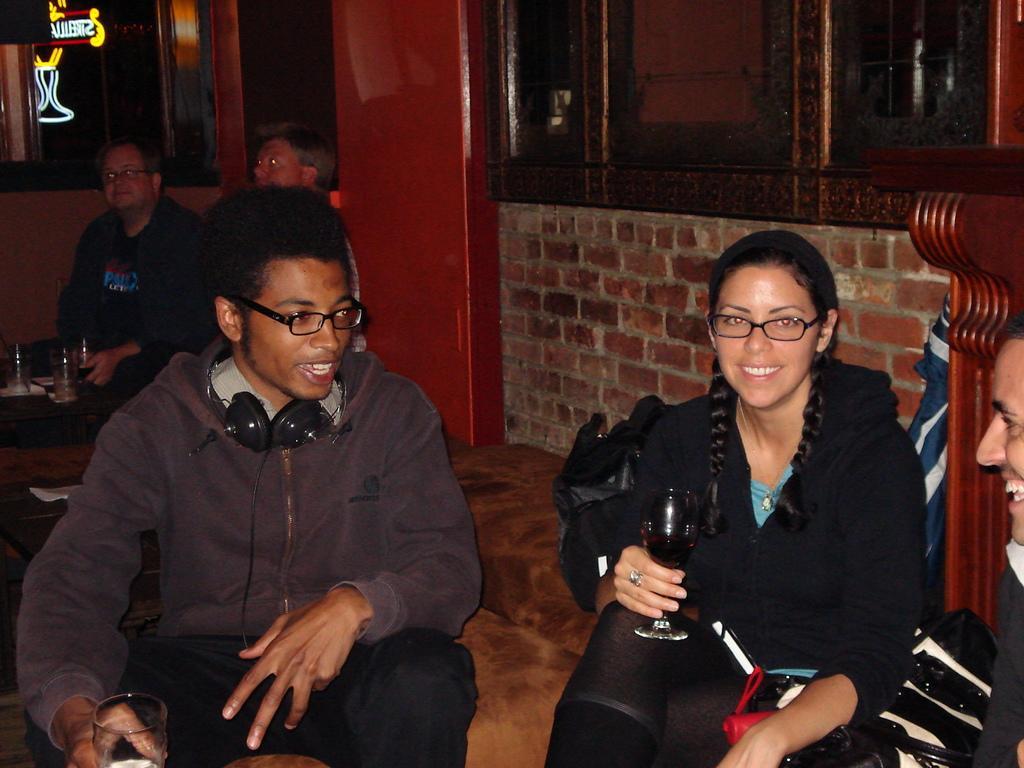Please provide a concise description of this image. In this image we can see people sitting and holding glasses. There are tables and chairs. In the background there is a wall and we can see windows. On the left there is a board. 